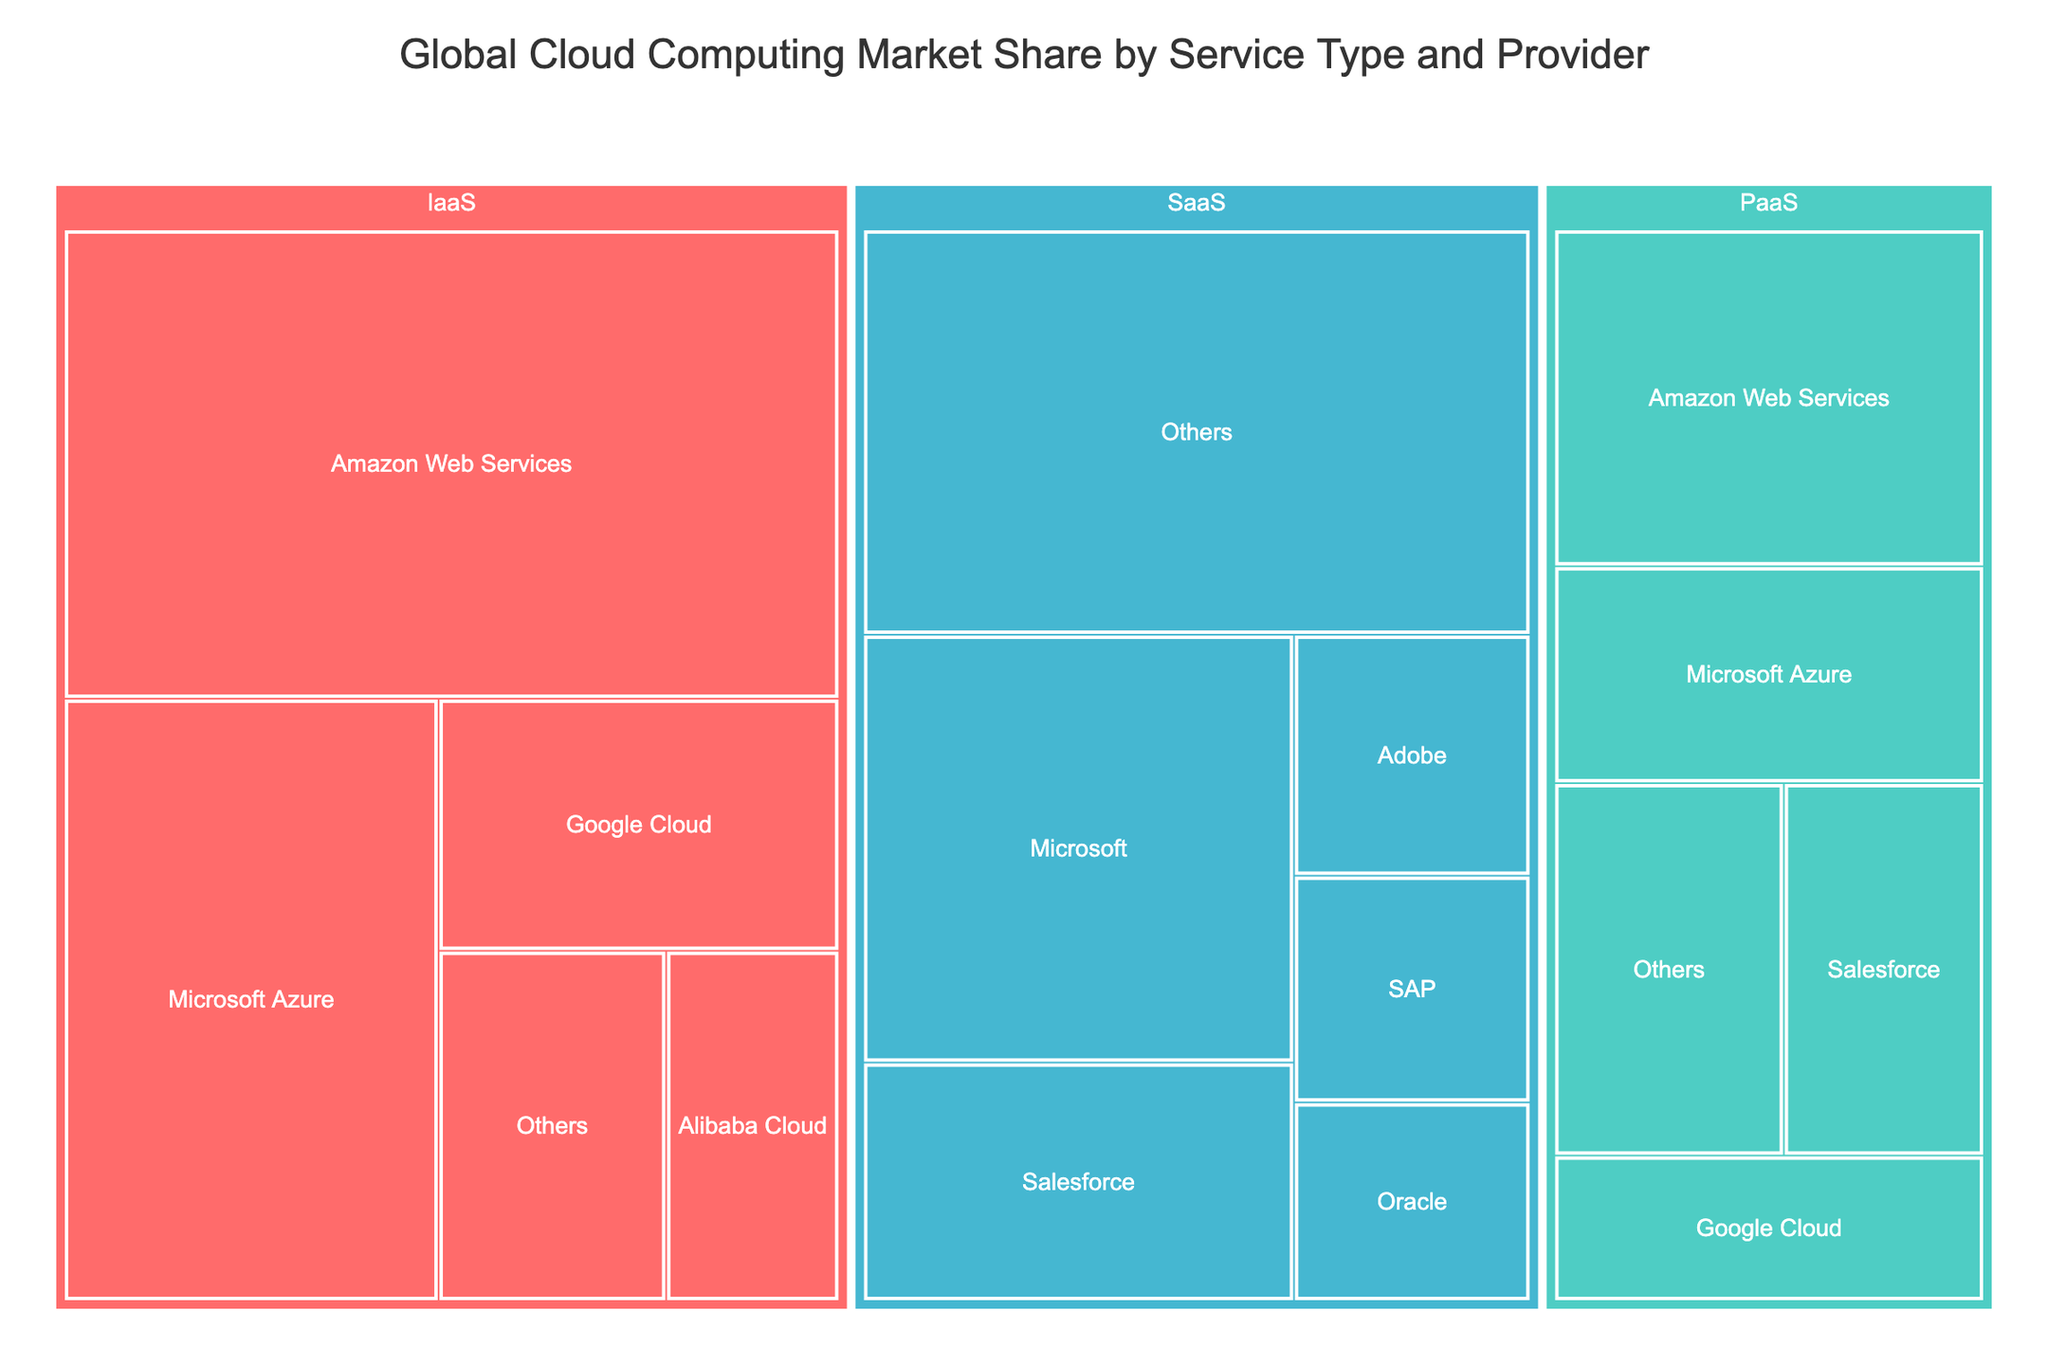What is the title of the figure? The title is displayed at the top of the treemap and reads "Global Cloud Computing Market Share by Service Type and Provider".
Answer: Global Cloud Computing Market Share by Service Type and Provider Which provider has the highest market share for IaaS? In the IaaS service type section, the largest segment is labeled "Amazon Web Services" with a market share of 32.4%.
Answer: Amazon Web Services How does the market share of Microsoft Azure compare between IaaS and PaaS? In the IaaS section, Microsoft Azure has a market share of 20.1%, and in the PaaS section, it has 8.5%. Comparing these values, the market share in IaaS is greater than in PaaS.
Answer: Greater in IaaS What is the total market share for the 'Others' category across all service types? Sum the market shares of 'Others' in IaaS (7.1%), PaaS (7.8%), and SaaS (24.2%). This gives 7.1 + 7.8 + 24.2 = 39.1%.
Answer: 39.1% Which Provider has the smallest market share in SaaS? In the SaaS section, the smallest segment is labeled “Oracle” with a market share of 4.2%.
Answer: Oracle What are the colors used to represent IaaS, PaaS, and SaaS? The colors are visualized in the treemap: IaaS is represented in red shades, PaaS in green shades, and SaaS in blue shades.
Answer: Red for IaaS, Green for PaaS, Blue for SaaS How does the market share of Salesforce for PaaS compare to its market share in SaaS? In the PaaS section, Salesforce has a market share of 6.8%, and in the SaaS section, it has a market share of 9.2%. Comparing these values, the market share in SaaS is greater than in PaaS.
Answer: Greater in SaaS What is the sum of the market shares of Adobe and SAP in the SaaS category? Adobe has a market share of 5.1% and SAP has a market share of 4.8% in the SaaS category. Therefore, the sum is 5.1 + 4.8 = 9.9%.
Answer: 9.9% What is the combined market share of Amazon Web Services across all service types? Amazon Web Services' market shares are 32.4% for IaaS and 13.2% for PaaS. Adding these values together gives 32.4 + 13.2 = 45.6%.
Answer: 45.6% Which service type has the highest market share represented by 'Others'? Looking at the sections in the treemap for IaaS, PaaS, and SaaS, the highest market share for 'Others' is in the SaaS section with 24.2%.
Answer: SaaS 